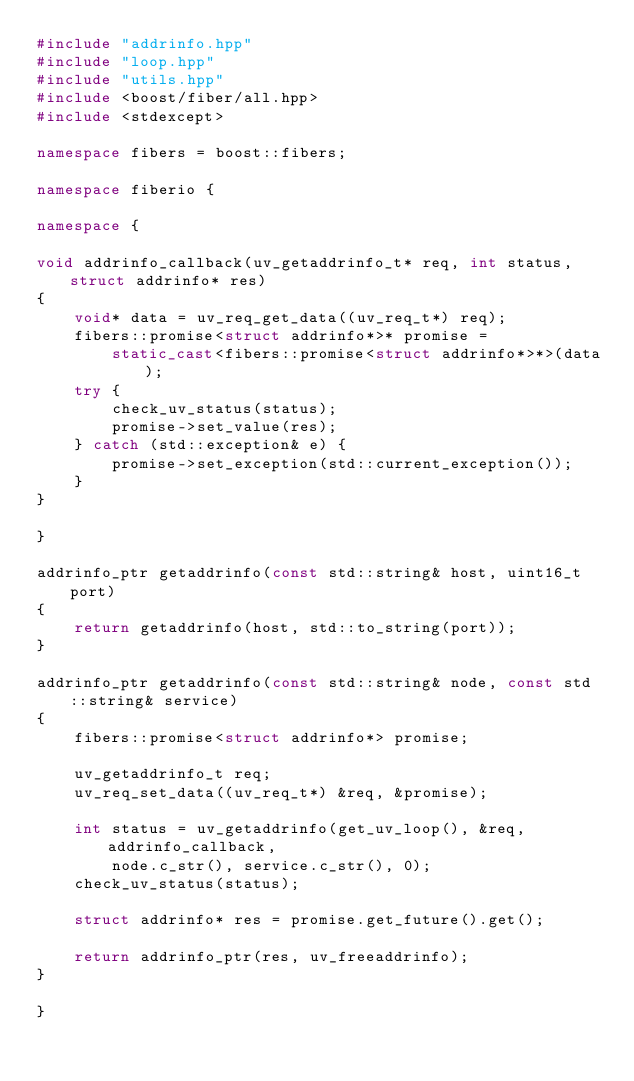<code> <loc_0><loc_0><loc_500><loc_500><_C++_>#include "addrinfo.hpp"
#include "loop.hpp"
#include "utils.hpp"
#include <boost/fiber/all.hpp>
#include <stdexcept>

namespace fibers = boost::fibers;

namespace fiberio {

namespace {

void addrinfo_callback(uv_getaddrinfo_t* req, int status, struct addrinfo* res)
{
    void* data = uv_req_get_data((uv_req_t*) req);
    fibers::promise<struct addrinfo*>* promise =
        static_cast<fibers::promise<struct addrinfo*>*>(data);
    try {
        check_uv_status(status);
        promise->set_value(res);
    } catch (std::exception& e) {
        promise->set_exception(std::current_exception());
    }
}

}

addrinfo_ptr getaddrinfo(const std::string& host, uint16_t port)
{
    return getaddrinfo(host, std::to_string(port));
}

addrinfo_ptr getaddrinfo(const std::string& node, const std::string& service)
{
    fibers::promise<struct addrinfo*> promise;

    uv_getaddrinfo_t req;
    uv_req_set_data((uv_req_t*) &req, &promise);

    int status = uv_getaddrinfo(get_uv_loop(), &req, addrinfo_callback,
        node.c_str(), service.c_str(), 0);
    check_uv_status(status);

    struct addrinfo* res = promise.get_future().get();

    return addrinfo_ptr(res, uv_freeaddrinfo);
}

}
</code> 